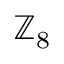<formula> <loc_0><loc_0><loc_500><loc_500>\mathbb { Z } _ { 8 }</formula> 